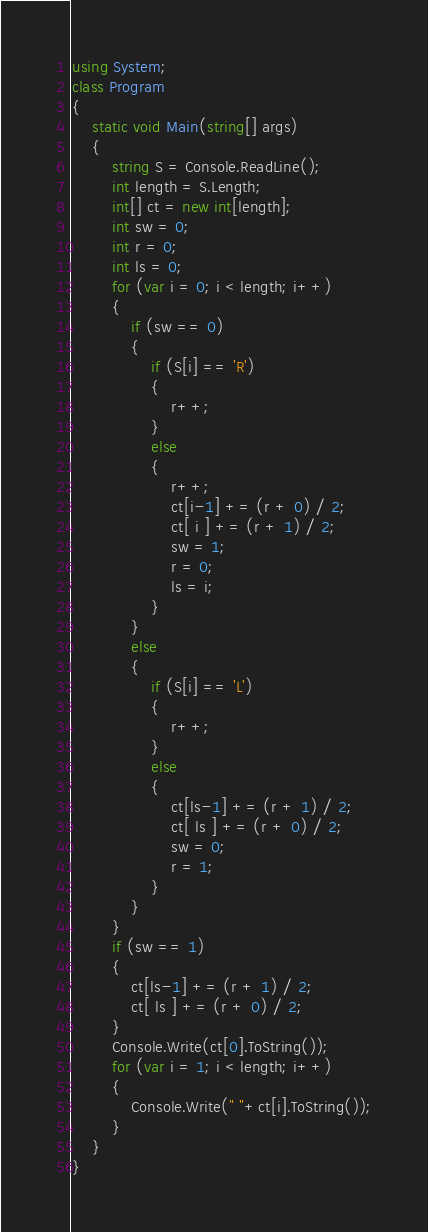<code> <loc_0><loc_0><loc_500><loc_500><_C#_>using System;
class Program
{
    static void Main(string[] args)
    {
        string S = Console.ReadLine();
        int length = S.Length;
        int[] ct = new int[length];
        int sw = 0;
        int r = 0;
        int ls = 0;
        for (var i = 0; i < length; i++)
        {
            if (sw == 0)
            {
                if (S[i] == 'R')
                {
                    r++;
                }
                else
                {
                    r++;
                    ct[i-1] += (r + 0) / 2;
                    ct[ i ] += (r + 1) / 2;
                    sw = 1;
                    r = 0;
                    ls = i;
                }
            }
            else
            {
                if (S[i] == 'L')
                {
                    r++;
                }
                else
                {
                    ct[ls-1] += (r + 1) / 2;
                    ct[ ls ] += (r + 0) / 2;
                    sw = 0;
                    r = 1;
                }
            }
        }
        if (sw == 1)
        {
            ct[ls-1] += (r + 1) / 2;
            ct[ ls ] += (r + 0) / 2;
        }
        Console.Write(ct[0].ToString());
        for (var i = 1; i < length; i++)
        {
            Console.Write(" "+ct[i].ToString());
        }
    }
}
</code> 